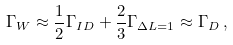<formula> <loc_0><loc_0><loc_500><loc_500>\Gamma _ { W } \approx \frac { 1 } { 2 } \Gamma _ { I D } + \frac { 2 } { 3 } \Gamma _ { \Delta L = 1 } \approx \Gamma _ { D } \, ,</formula> 